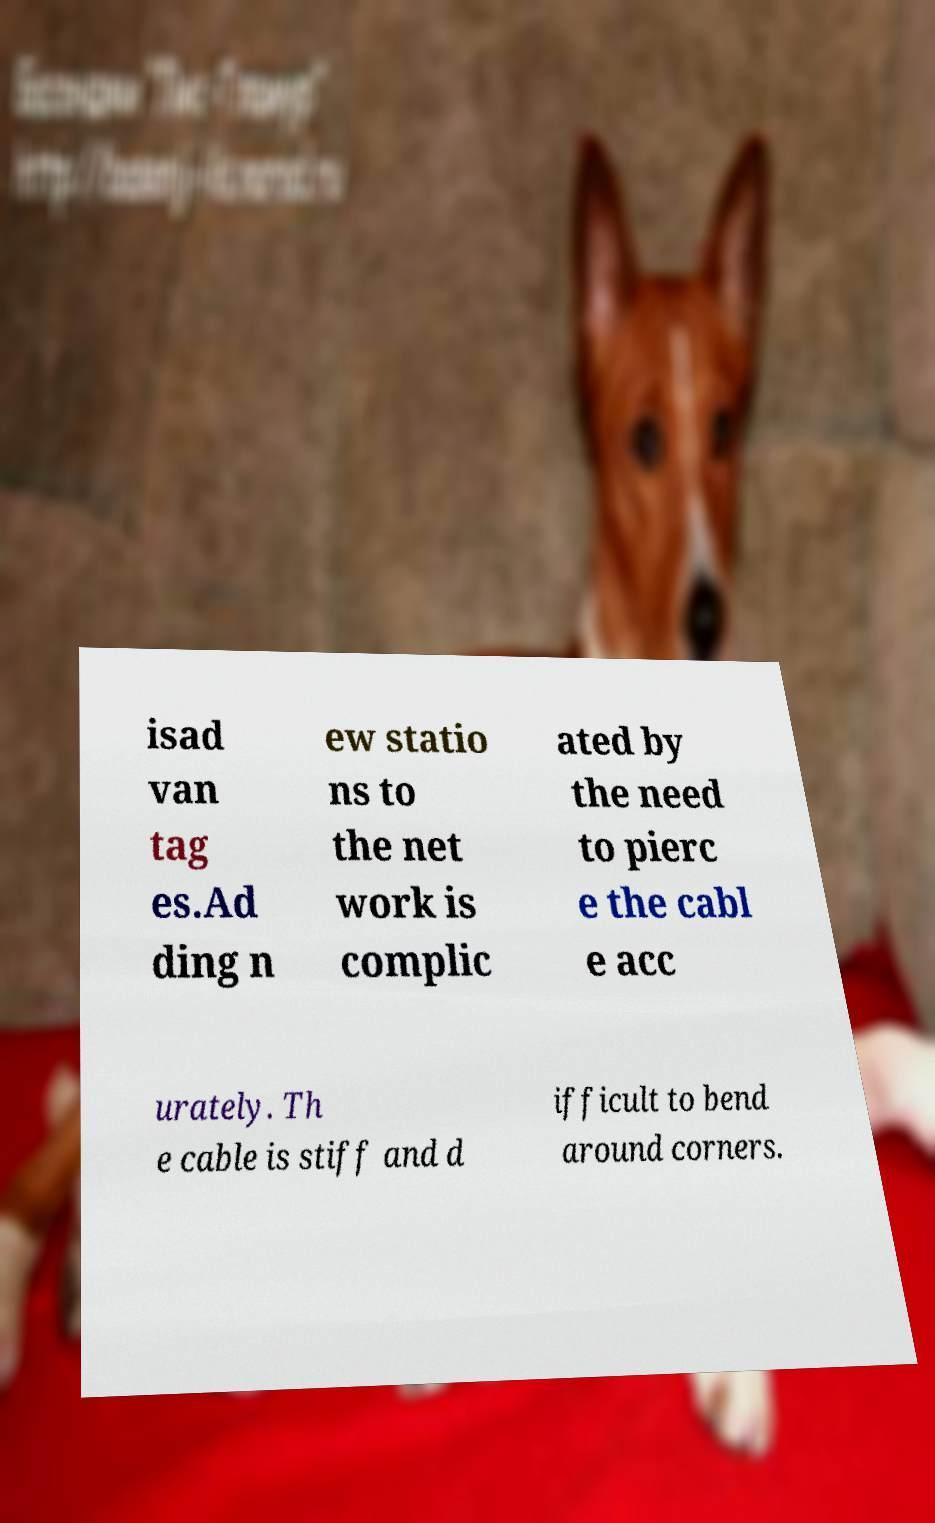For documentation purposes, I need the text within this image transcribed. Could you provide that? isad van tag es.Ad ding n ew statio ns to the net work is complic ated by the need to pierc e the cabl e acc urately. Th e cable is stiff and d ifficult to bend around corners. 